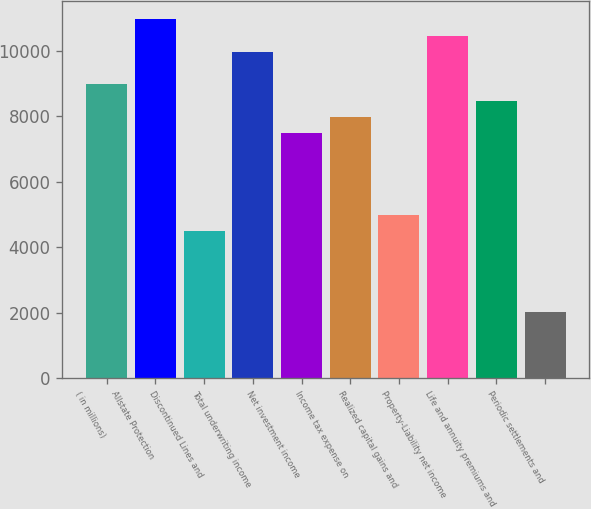Convert chart to OTSL. <chart><loc_0><loc_0><loc_500><loc_500><bar_chart><fcel>( in millions)<fcel>Allstate Protection<fcel>Discontinued Lines and<fcel>Total underwriting income<fcel>Net investment income<fcel>Income tax expense on<fcel>Realized capital gains and<fcel>Property-Liability net income<fcel>Life and annuity premiums and<fcel>Periodic settlements and<nl><fcel>8979.4<fcel>10972.6<fcel>4494.7<fcel>9976<fcel>7484.5<fcel>7982.8<fcel>4993<fcel>10474.3<fcel>8481.1<fcel>2003.2<nl></chart> 